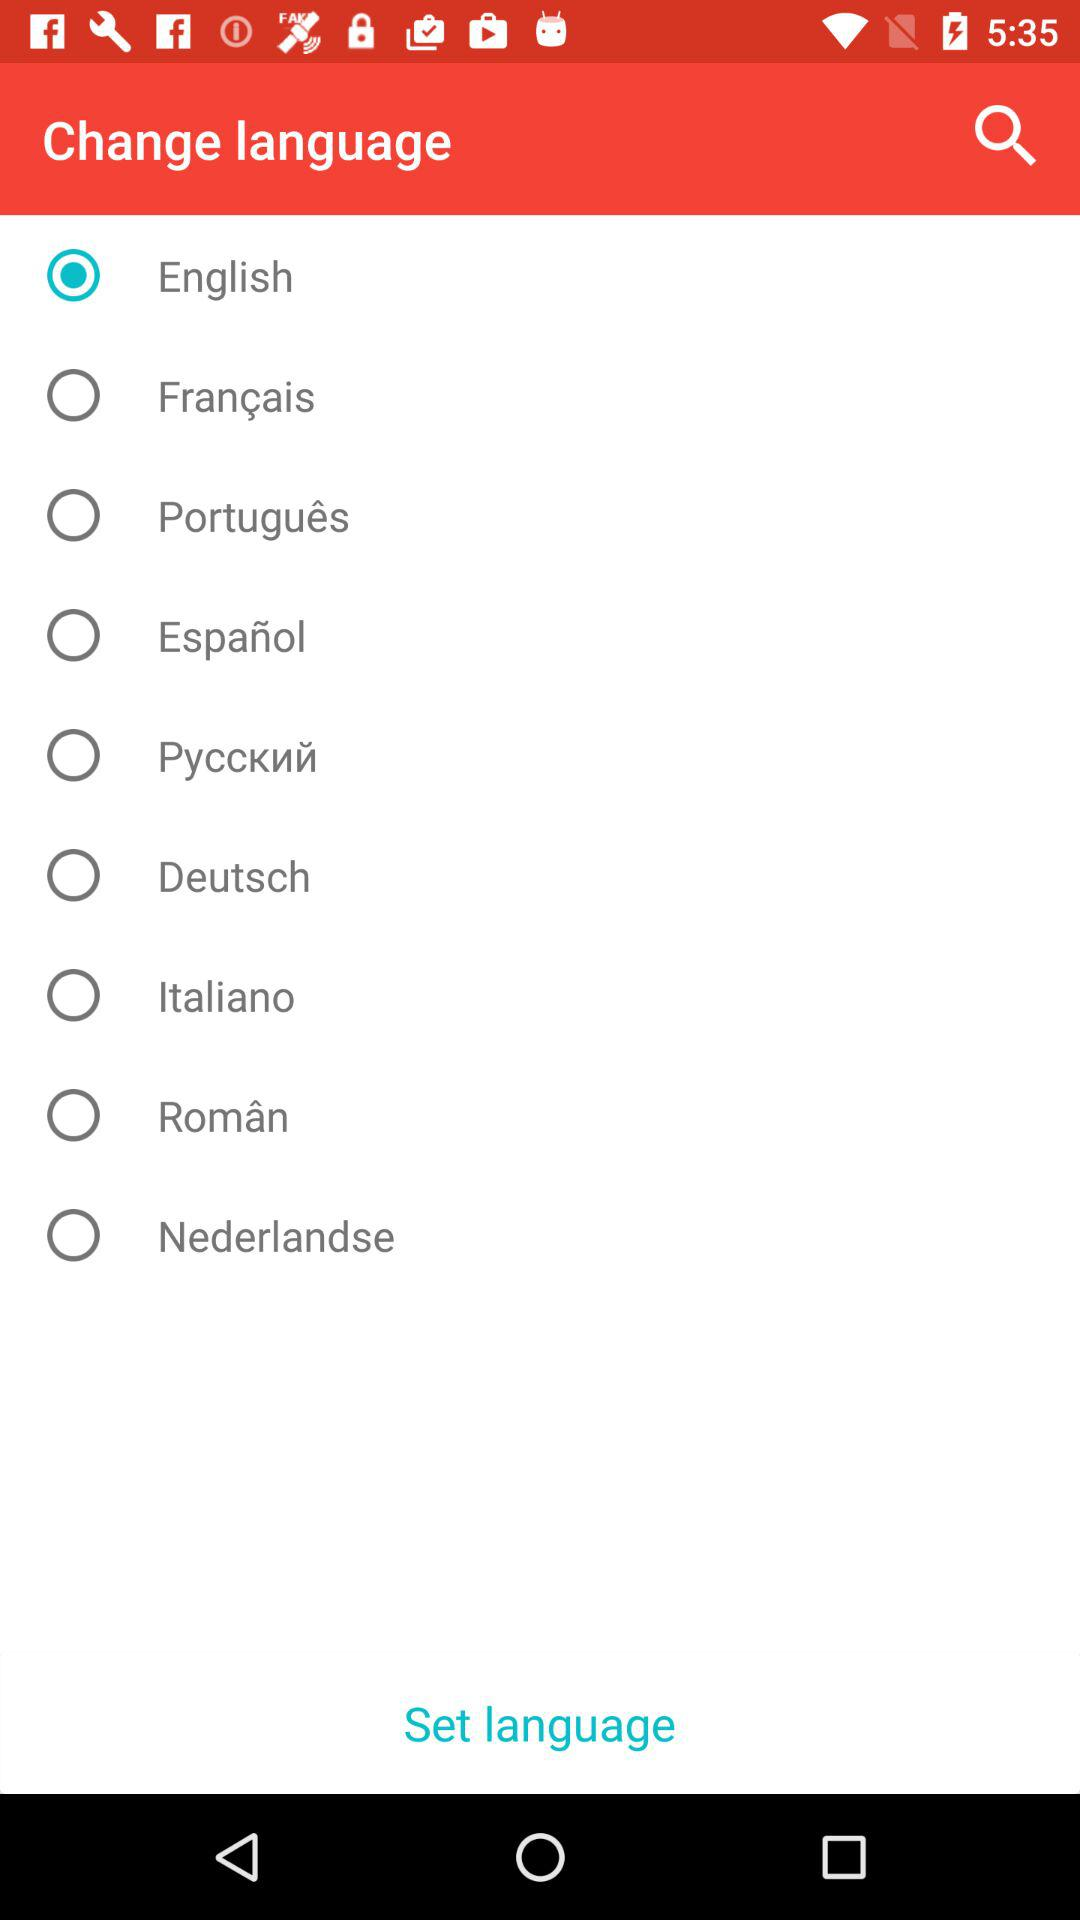Which option is selected? The selected option is "English". 